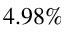<formula> <loc_0><loc_0><loc_500><loc_500>4 . 9 8 \%</formula> 